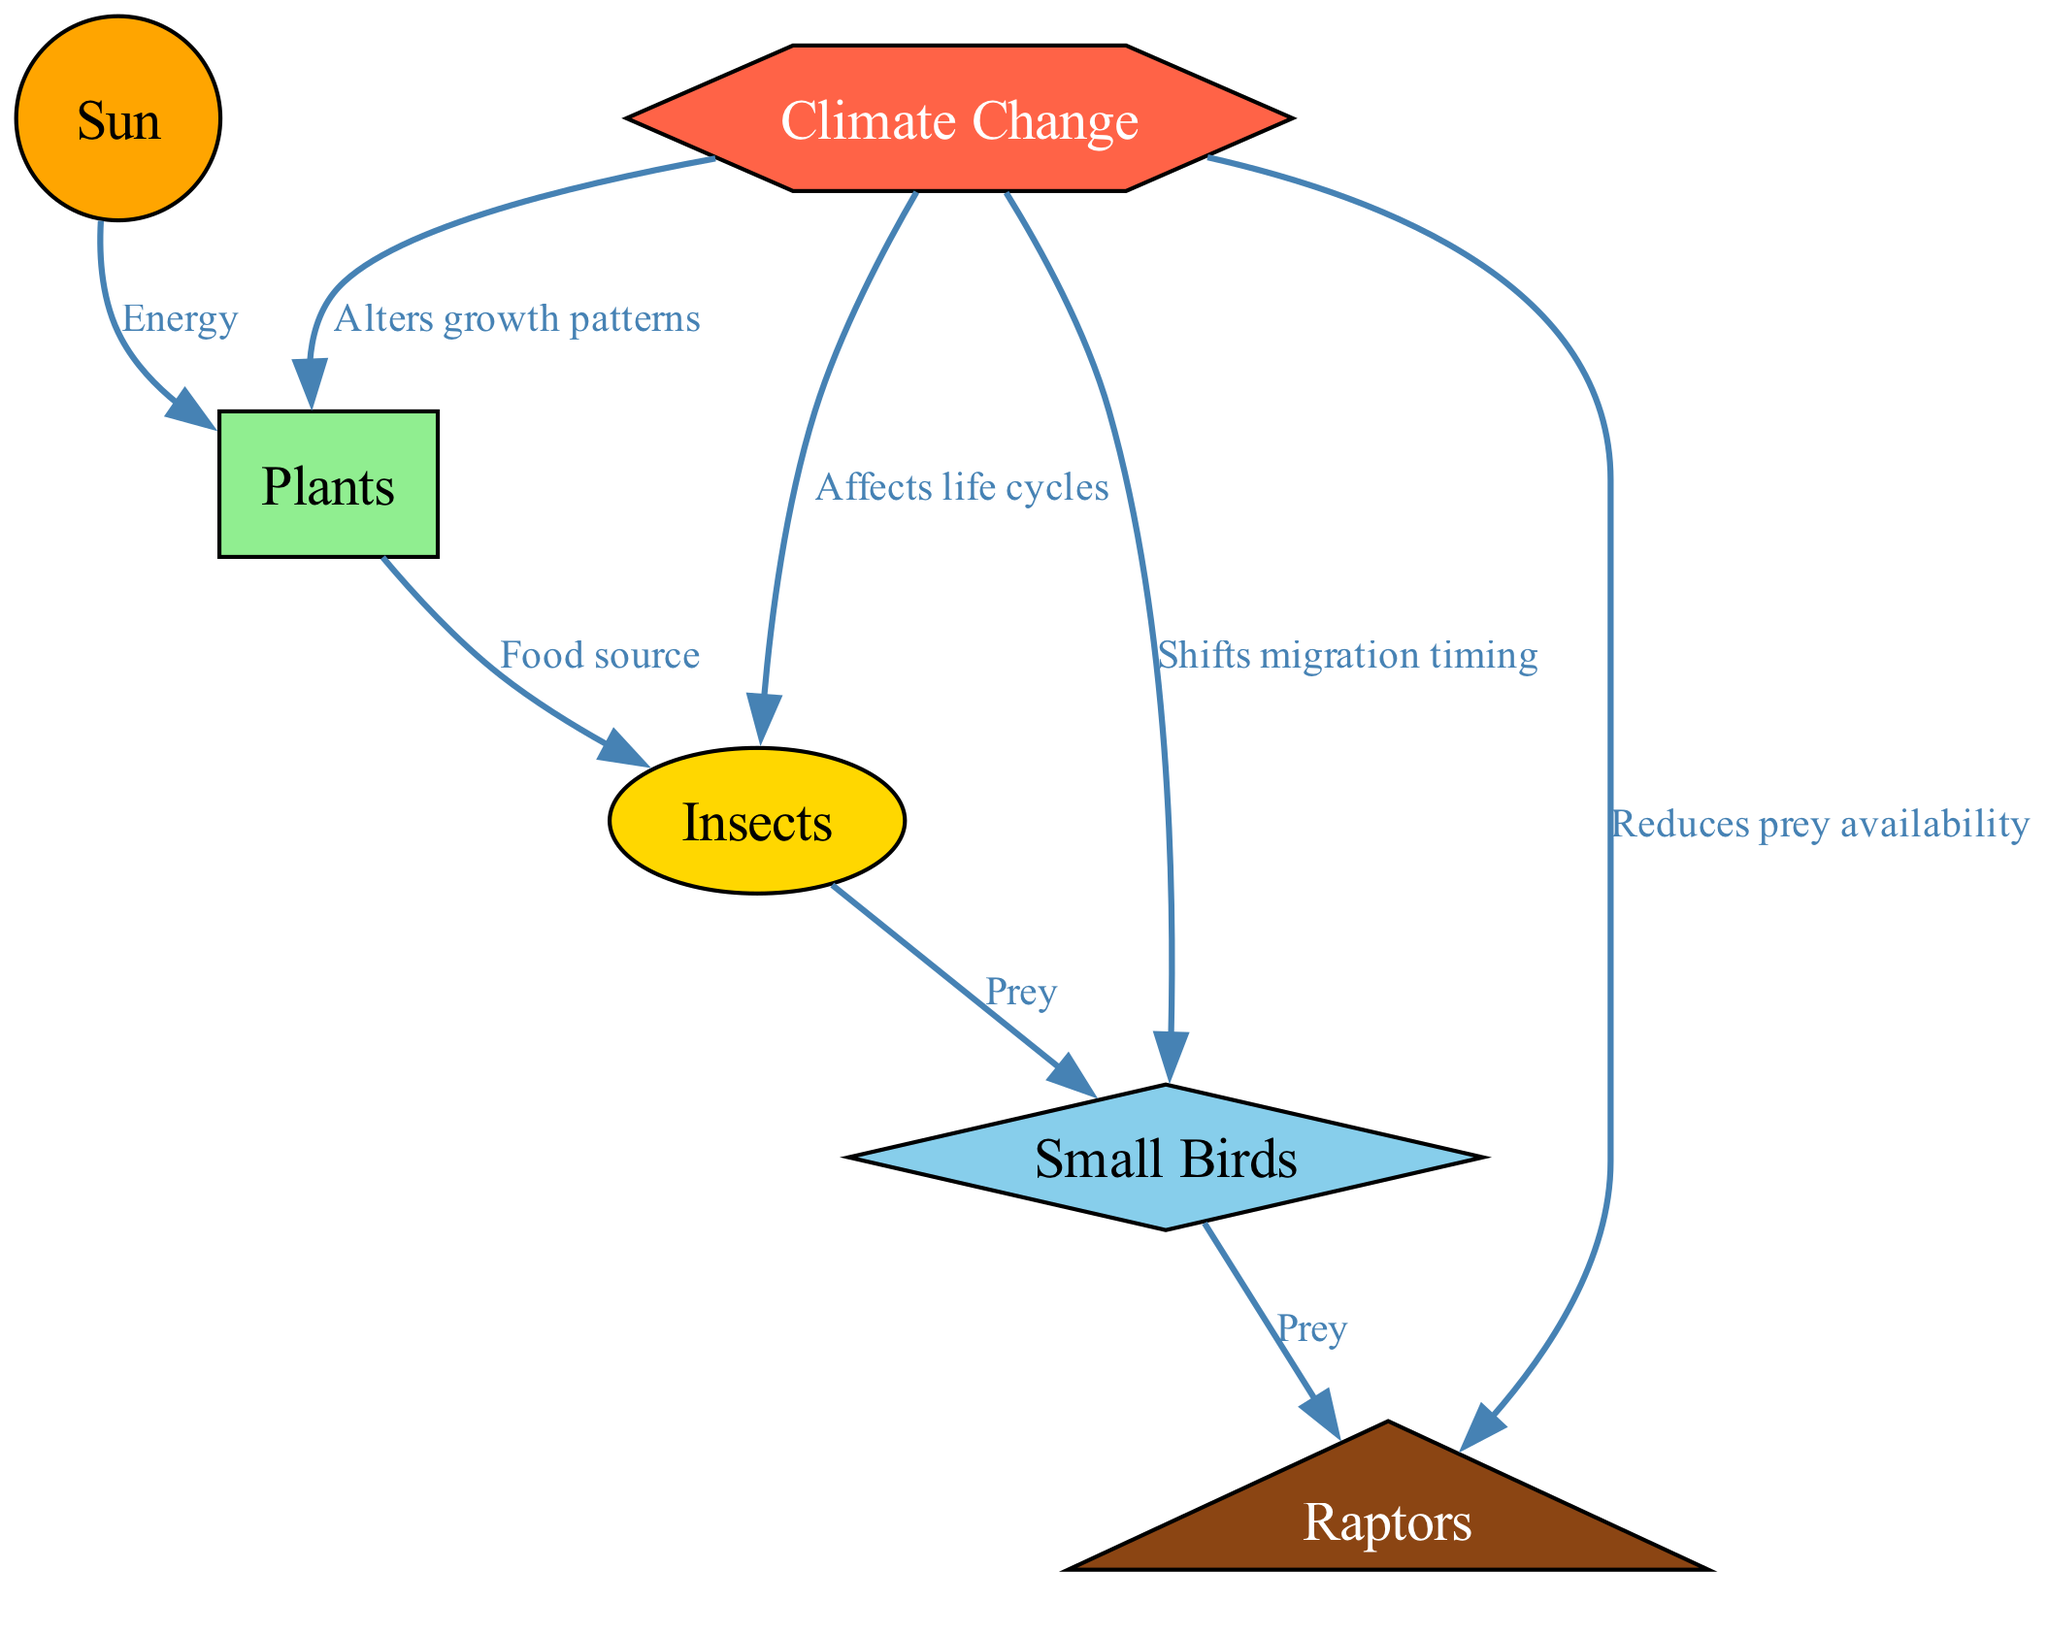What is the role of the sun in the food web? The sun is the primary energy source in the food web, as indicated by the edge labeled "Energy" connecting the sun to the plants. This relationship shows that plants rely on the sun to produce energy through photosynthesis.
Answer: Energy How many edges are there in the diagram? To find the number of edges, count each connection between nodes. The diagram has 8 edges as listed between various nodes, including relationships from the sun, climate change, and prey interactions between birds and insects.
Answer: 8 What do insects depend on for food? The edge labeled "Food source" connects plants to insects, indicating that insects rely on plants for their nutritional needs.
Answer: Plants How does climate change affect small birds? The edge connected to small birds labeled "Shifts migration timing" shows that climate change impacts their migration, which can affect their survival and reproductive success.
Answer: Shifts migration timing What is the consequence of climate change on raptors? The diagram shows that climate change "Reduces prey availability" for raptors, indicating that changes in climate can lead to a decrease in their food sources, specifically small birds, which they rely on for sustenance.
Answer: Reduces prey availability Which node represents a primary producer? In the diagram, plants are identified as the primary producers because they convert sunlight into energy through photosynthesis, which is essential for the food web.
Answer: Plants What connections exist between insects and small birds? The relationship is represented by the edge labeled "Prey," indicating that insects serve as prey for small birds, highlighting their role in the food web.
Answer: Prey In the context of climate change, which node is directly affected? The node for climate change directly affects plants, insects, small birds, and raptors, as illustrated by the edges drawn from the climate change node to these respective nodes, representing its influence across the food web.
Answer: Plants, insects, small birds, raptors What shape represents the raptors in the diagram? According to the node styles, raptors are represented by a triangle shape in the diagram, emphasizing their place in this multi-level food web.
Answer: Triangle 